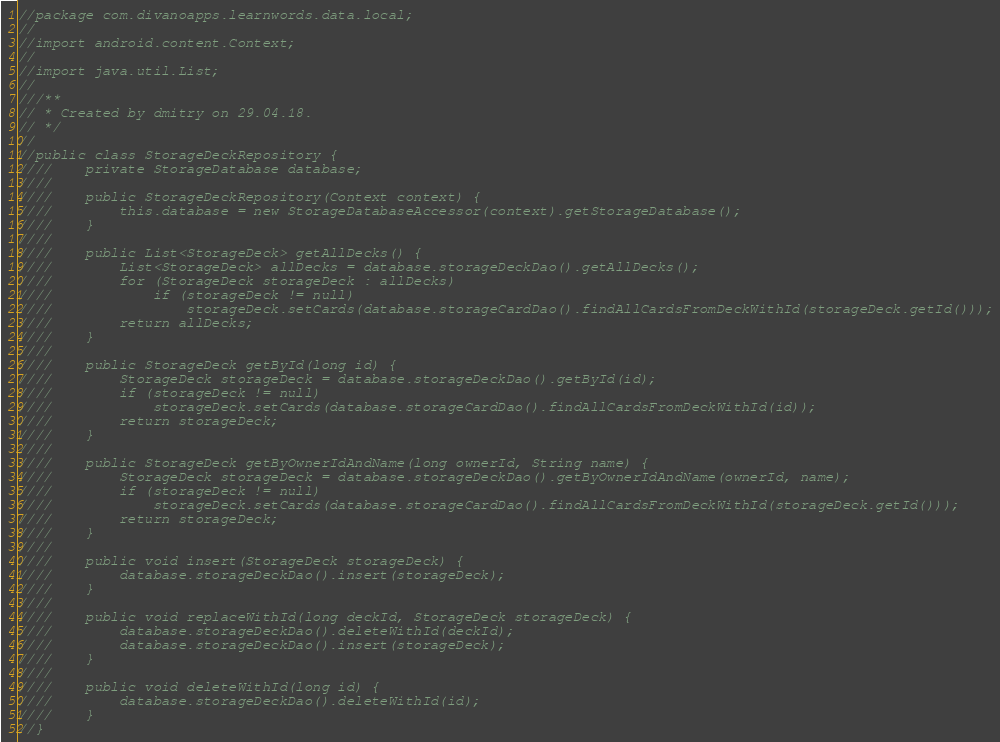Convert code to text. <code><loc_0><loc_0><loc_500><loc_500><_Java_>//package com.divanoapps.learnwords.data.local;
//
//import android.content.Context;
//
//import java.util.List;
//
///**
// * Created by dmitry on 29.04.18.
// */
//
//public class StorageDeckRepository {
////    private StorageDatabase database;
////
////    public StorageDeckRepository(Context context) {
////        this.database = new StorageDatabaseAccessor(context).getStorageDatabase();
////    }
////
////    public List<StorageDeck> getAllDecks() {
////        List<StorageDeck> allDecks = database.storageDeckDao().getAllDecks();
////        for (StorageDeck storageDeck : allDecks)
////            if (storageDeck != null)
////                storageDeck.setCards(database.storageCardDao().findAllCardsFromDeckWithId(storageDeck.getId()));
////        return allDecks;
////    }
////
////    public StorageDeck getById(long id) {
////        StorageDeck storageDeck = database.storageDeckDao().getById(id);
////        if (storageDeck != null)
////            storageDeck.setCards(database.storageCardDao().findAllCardsFromDeckWithId(id));
////        return storageDeck;
////    }
////
////    public StorageDeck getByOwnerIdAndName(long ownerId, String name) {
////        StorageDeck storageDeck = database.storageDeckDao().getByOwnerIdAndName(ownerId, name);
////        if (storageDeck != null)
////            storageDeck.setCards(database.storageCardDao().findAllCardsFromDeckWithId(storageDeck.getId()));
////        return storageDeck;
////    }
////
////    public void insert(StorageDeck storageDeck) {
////        database.storageDeckDao().insert(storageDeck);
////    }
////
////    public void replaceWithId(long deckId, StorageDeck storageDeck) {
////        database.storageDeckDao().deleteWithId(deckId);
////        database.storageDeckDao().insert(storageDeck);
////    }
////
////    public void deleteWithId(long id) {
////        database.storageDeckDao().deleteWithId(id);
////    }
//}
</code> 